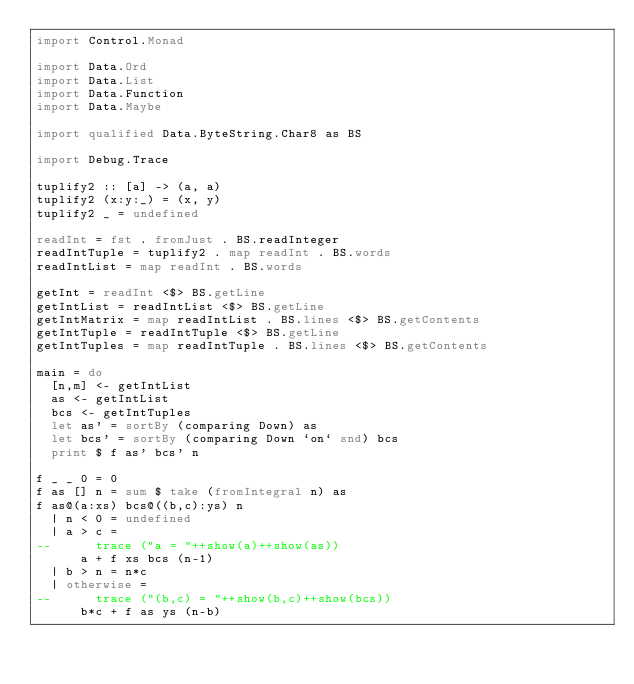Convert code to text. <code><loc_0><loc_0><loc_500><loc_500><_Haskell_>import Control.Monad

import Data.Ord
import Data.List
import Data.Function
import Data.Maybe

import qualified Data.ByteString.Char8 as BS

import Debug.Trace

tuplify2 :: [a] -> (a, a)
tuplify2 (x:y:_) = (x, y)
tuplify2 _ = undefined

readInt = fst . fromJust . BS.readInteger
readIntTuple = tuplify2 . map readInt . BS.words
readIntList = map readInt . BS.words

getInt = readInt <$> BS.getLine
getIntList = readIntList <$> BS.getLine
getIntMatrix = map readIntList . BS.lines <$> BS.getContents
getIntTuple = readIntTuple <$> BS.getLine
getIntTuples = map readIntTuple . BS.lines <$> BS.getContents

main = do
  [n,m] <- getIntList
  as <- getIntList
  bcs <- getIntTuples
  let as' = sortBy (comparing Down) as
  let bcs' = sortBy (comparing Down `on` snd) bcs
  print $ f as' bcs' n

f _ _ 0 = 0
f as [] n = sum $ take (fromIntegral n) as
f as@(a:xs) bcs@((b,c):ys) n
  | n < 0 = undefined
  | a > c =
--      trace ("a = "++show(a)++show(as))
      a + f xs bcs (n-1)
  | b > n = n*c
  | otherwise =
--      trace ("(b,c) = "++show(b,c)++show(bcs))
      b*c + f as ys (n-b)</code> 